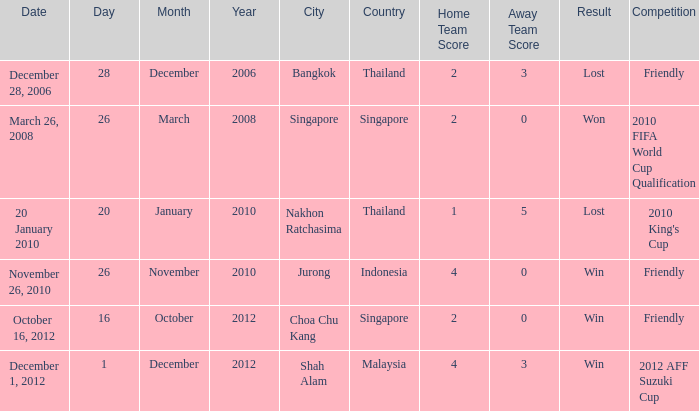Name the venue for friendly competition october 16, 2012 Choa Chu Kang , Singapore. 